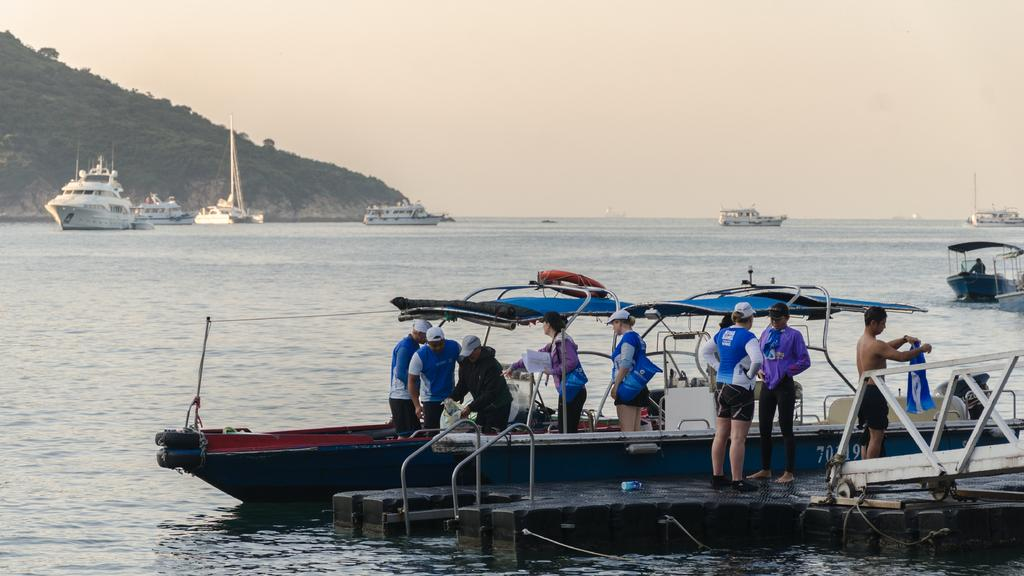Who or what can be seen in the image? There are people in the image. What are the people doing in the image? The provided facts do not specify what the people are doing. What is located above the water in the image? There are boats above the water in the image. What can be seen in the background of the image? There are ships, trees, and the sky visible in the background of the image. What type of insurance is being discussed by the people in the image? There is no indication in the image that the people are discussing insurance or any other topic. 